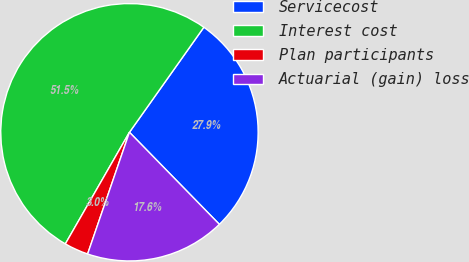<chart> <loc_0><loc_0><loc_500><loc_500><pie_chart><fcel>Servicecost<fcel>Interest cost<fcel>Plan participants<fcel>Actuarial (gain) loss<nl><fcel>27.88%<fcel>51.52%<fcel>3.03%<fcel>17.58%<nl></chart> 